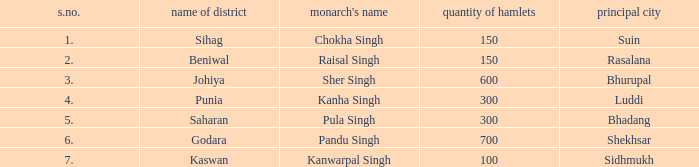What is the highest S number with a capital of Shekhsar? 6.0. 